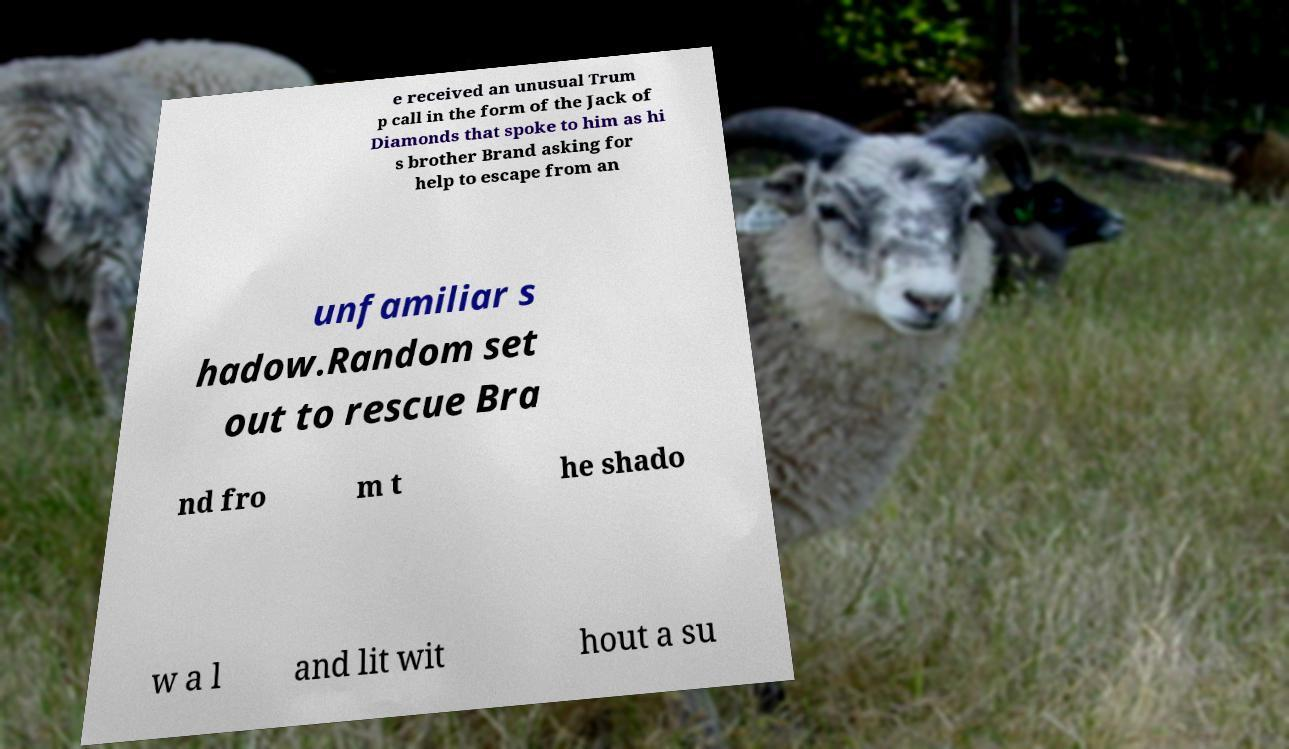Please read and relay the text visible in this image. What does it say? e received an unusual Trum p call in the form of the Jack of Diamonds that spoke to him as hi s brother Brand asking for help to escape from an unfamiliar s hadow.Random set out to rescue Bra nd fro m t he shado w a l and lit wit hout a su 